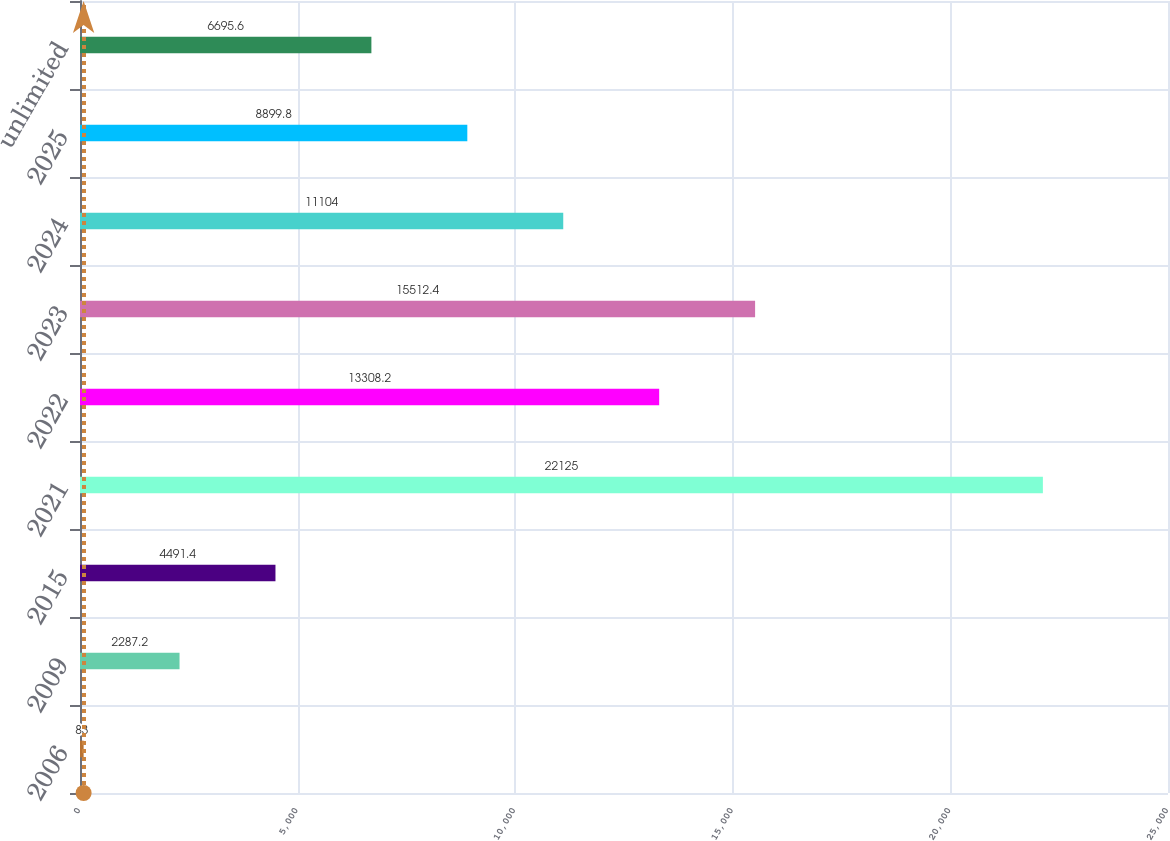Convert chart. <chart><loc_0><loc_0><loc_500><loc_500><bar_chart><fcel>2006<fcel>2009<fcel>2015<fcel>2021<fcel>2022<fcel>2023<fcel>2024<fcel>2025<fcel>unlimited<nl><fcel>83<fcel>2287.2<fcel>4491.4<fcel>22125<fcel>13308.2<fcel>15512.4<fcel>11104<fcel>8899.8<fcel>6695.6<nl></chart> 